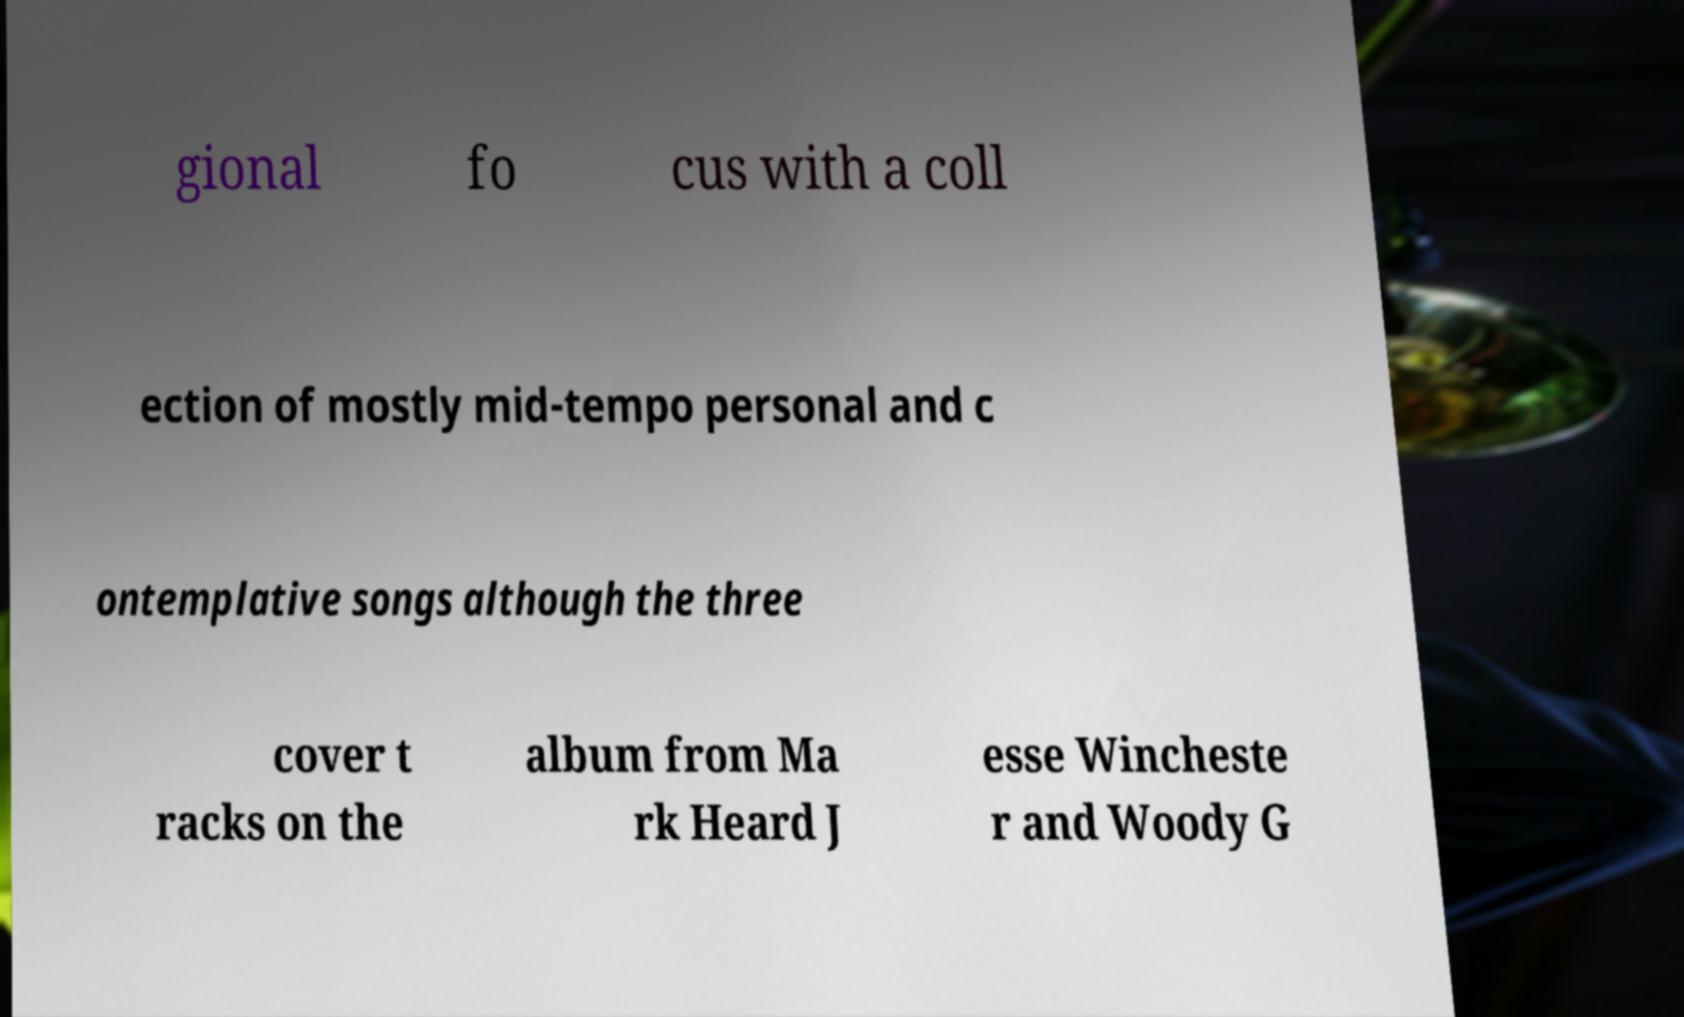What messages or text are displayed in this image? I need them in a readable, typed format. gional fo cus with a coll ection of mostly mid-tempo personal and c ontemplative songs although the three cover t racks on the album from Ma rk Heard J esse Wincheste r and Woody G 